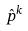<formula> <loc_0><loc_0><loc_500><loc_500>\hat { p } ^ { k }</formula> 